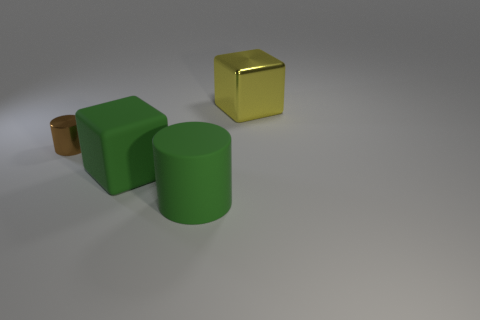The green thing on the left side of the matte cylinder has what shape?
Ensure brevity in your answer.  Cube. Are there any other things that are the same shape as the big metallic object?
Offer a terse response. Yes. Are there any large yellow metallic balls?
Offer a very short reply. No. Does the cylinder that is to the right of the metallic cylinder have the same size as the shiny object that is on the right side of the large rubber block?
Your answer should be very brief. Yes. What is the thing that is to the left of the large green rubber cylinder and right of the small brown object made of?
Your answer should be very brief. Rubber. How many matte cylinders are in front of the small brown shiny cylinder?
Your answer should be compact. 1. Are there any other things that are the same size as the yellow metallic thing?
Offer a very short reply. Yes. What is the color of the cube that is made of the same material as the green cylinder?
Make the answer very short. Green. Do the small brown shiny thing and the yellow thing have the same shape?
Your answer should be very brief. No. What number of large things are both behind the green matte cylinder and in front of the brown metal cylinder?
Offer a terse response. 1. 